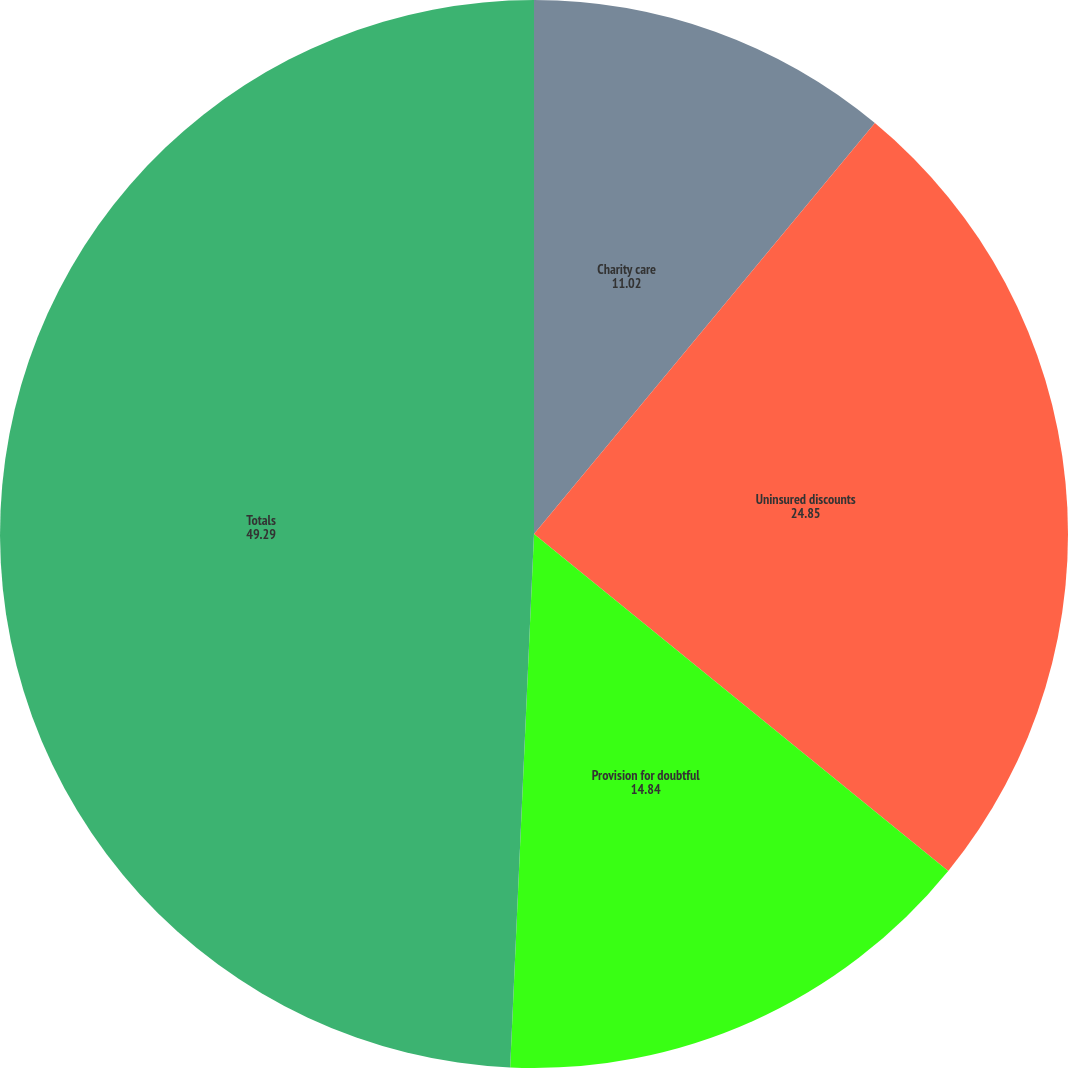<chart> <loc_0><loc_0><loc_500><loc_500><pie_chart><fcel>Charity care<fcel>Uninsured discounts<fcel>Provision for doubtful<fcel>Totals<nl><fcel>11.02%<fcel>24.85%<fcel>14.84%<fcel>49.29%<nl></chart> 